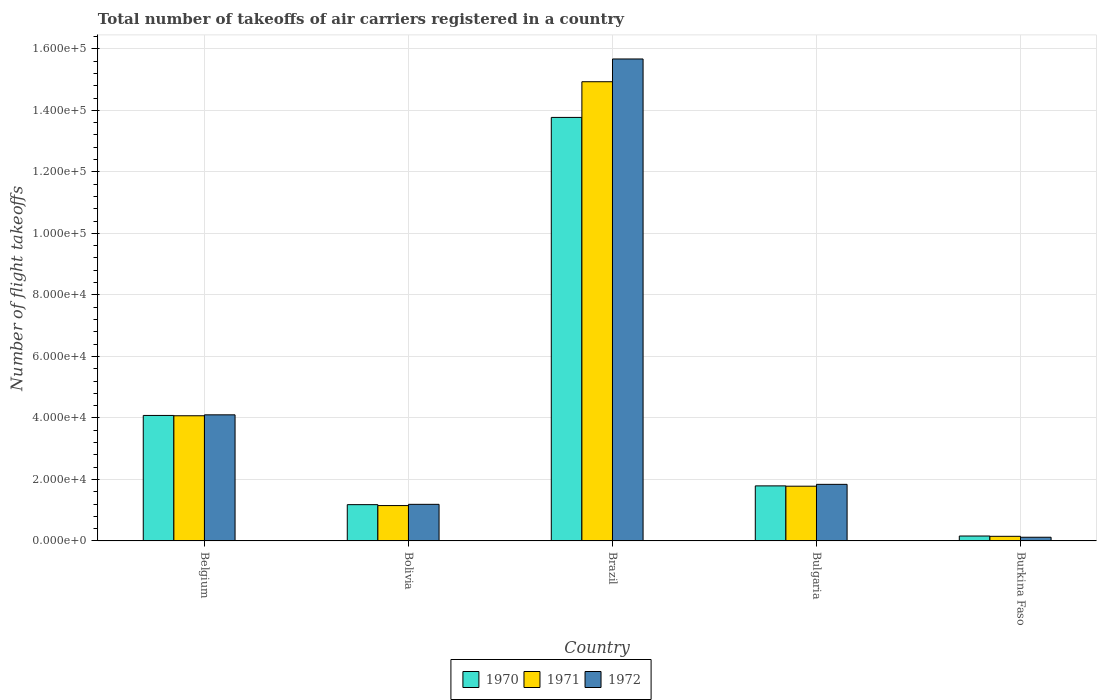What is the label of the 2nd group of bars from the left?
Provide a short and direct response. Bolivia. What is the total number of flight takeoffs in 1972 in Bulgaria?
Your answer should be compact. 1.84e+04. Across all countries, what is the maximum total number of flight takeoffs in 1971?
Keep it short and to the point. 1.49e+05. Across all countries, what is the minimum total number of flight takeoffs in 1971?
Give a very brief answer. 1500. In which country was the total number of flight takeoffs in 1972 minimum?
Make the answer very short. Burkina Faso. What is the total total number of flight takeoffs in 1971 in the graph?
Offer a terse response. 2.21e+05. What is the difference between the total number of flight takeoffs in 1970 in Belgium and that in Burkina Faso?
Provide a succinct answer. 3.92e+04. What is the difference between the total number of flight takeoffs in 1971 in Belgium and the total number of flight takeoffs in 1970 in Bulgaria?
Offer a very short reply. 2.28e+04. What is the average total number of flight takeoffs in 1971 per country?
Provide a succinct answer. 4.42e+04. What is the difference between the total number of flight takeoffs of/in 1970 and total number of flight takeoffs of/in 1972 in Belgium?
Offer a terse response. -200. What is the ratio of the total number of flight takeoffs in 1972 in Bolivia to that in Burkina Faso?
Your response must be concise. 9.92. Is the total number of flight takeoffs in 1972 in Bolivia less than that in Bulgaria?
Your answer should be compact. Yes. What is the difference between the highest and the second highest total number of flight takeoffs in 1972?
Your answer should be compact. 2.26e+04. What is the difference between the highest and the lowest total number of flight takeoffs in 1972?
Provide a succinct answer. 1.56e+05. In how many countries, is the total number of flight takeoffs in 1972 greater than the average total number of flight takeoffs in 1972 taken over all countries?
Offer a very short reply. 1. Is the sum of the total number of flight takeoffs in 1971 in Belgium and Brazil greater than the maximum total number of flight takeoffs in 1972 across all countries?
Your answer should be very brief. Yes. Is it the case that in every country, the sum of the total number of flight takeoffs in 1970 and total number of flight takeoffs in 1972 is greater than the total number of flight takeoffs in 1971?
Your answer should be compact. Yes. Are all the bars in the graph horizontal?
Keep it short and to the point. No. Are the values on the major ticks of Y-axis written in scientific E-notation?
Offer a very short reply. Yes. Does the graph contain grids?
Make the answer very short. Yes. How many legend labels are there?
Ensure brevity in your answer.  3. How are the legend labels stacked?
Provide a succinct answer. Horizontal. What is the title of the graph?
Provide a succinct answer. Total number of takeoffs of air carriers registered in a country. What is the label or title of the X-axis?
Offer a very short reply. Country. What is the label or title of the Y-axis?
Offer a terse response. Number of flight takeoffs. What is the Number of flight takeoffs of 1970 in Belgium?
Your response must be concise. 4.08e+04. What is the Number of flight takeoffs in 1971 in Belgium?
Your response must be concise. 4.07e+04. What is the Number of flight takeoffs of 1972 in Belgium?
Provide a succinct answer. 4.10e+04. What is the Number of flight takeoffs of 1970 in Bolivia?
Offer a terse response. 1.18e+04. What is the Number of flight takeoffs in 1971 in Bolivia?
Keep it short and to the point. 1.15e+04. What is the Number of flight takeoffs in 1972 in Bolivia?
Keep it short and to the point. 1.19e+04. What is the Number of flight takeoffs of 1970 in Brazil?
Offer a very short reply. 1.38e+05. What is the Number of flight takeoffs of 1971 in Brazil?
Offer a terse response. 1.49e+05. What is the Number of flight takeoffs in 1972 in Brazil?
Your answer should be very brief. 1.57e+05. What is the Number of flight takeoffs of 1970 in Bulgaria?
Your answer should be very brief. 1.79e+04. What is the Number of flight takeoffs of 1971 in Bulgaria?
Keep it short and to the point. 1.78e+04. What is the Number of flight takeoffs of 1972 in Bulgaria?
Offer a terse response. 1.84e+04. What is the Number of flight takeoffs in 1970 in Burkina Faso?
Your answer should be very brief. 1600. What is the Number of flight takeoffs of 1971 in Burkina Faso?
Your response must be concise. 1500. What is the Number of flight takeoffs in 1972 in Burkina Faso?
Make the answer very short. 1200. Across all countries, what is the maximum Number of flight takeoffs of 1970?
Offer a very short reply. 1.38e+05. Across all countries, what is the maximum Number of flight takeoffs of 1971?
Keep it short and to the point. 1.49e+05. Across all countries, what is the maximum Number of flight takeoffs of 1972?
Give a very brief answer. 1.57e+05. Across all countries, what is the minimum Number of flight takeoffs of 1970?
Your answer should be compact. 1600. Across all countries, what is the minimum Number of flight takeoffs of 1971?
Your answer should be very brief. 1500. Across all countries, what is the minimum Number of flight takeoffs in 1972?
Keep it short and to the point. 1200. What is the total Number of flight takeoffs of 1970 in the graph?
Make the answer very short. 2.10e+05. What is the total Number of flight takeoffs in 1971 in the graph?
Your response must be concise. 2.21e+05. What is the total Number of flight takeoffs in 1972 in the graph?
Offer a terse response. 2.29e+05. What is the difference between the Number of flight takeoffs in 1970 in Belgium and that in Bolivia?
Your answer should be very brief. 2.90e+04. What is the difference between the Number of flight takeoffs in 1971 in Belgium and that in Bolivia?
Your response must be concise. 2.92e+04. What is the difference between the Number of flight takeoffs in 1972 in Belgium and that in Bolivia?
Your response must be concise. 2.91e+04. What is the difference between the Number of flight takeoffs in 1970 in Belgium and that in Brazil?
Your answer should be very brief. -9.69e+04. What is the difference between the Number of flight takeoffs in 1971 in Belgium and that in Brazil?
Offer a terse response. -1.09e+05. What is the difference between the Number of flight takeoffs of 1972 in Belgium and that in Brazil?
Give a very brief answer. -1.16e+05. What is the difference between the Number of flight takeoffs of 1970 in Belgium and that in Bulgaria?
Your answer should be compact. 2.29e+04. What is the difference between the Number of flight takeoffs of 1971 in Belgium and that in Bulgaria?
Provide a short and direct response. 2.29e+04. What is the difference between the Number of flight takeoffs of 1972 in Belgium and that in Bulgaria?
Ensure brevity in your answer.  2.26e+04. What is the difference between the Number of flight takeoffs in 1970 in Belgium and that in Burkina Faso?
Give a very brief answer. 3.92e+04. What is the difference between the Number of flight takeoffs of 1971 in Belgium and that in Burkina Faso?
Offer a very short reply. 3.92e+04. What is the difference between the Number of flight takeoffs of 1972 in Belgium and that in Burkina Faso?
Give a very brief answer. 3.98e+04. What is the difference between the Number of flight takeoffs in 1970 in Bolivia and that in Brazil?
Provide a short and direct response. -1.26e+05. What is the difference between the Number of flight takeoffs in 1971 in Bolivia and that in Brazil?
Keep it short and to the point. -1.38e+05. What is the difference between the Number of flight takeoffs of 1972 in Bolivia and that in Brazil?
Offer a very short reply. -1.45e+05. What is the difference between the Number of flight takeoffs of 1970 in Bolivia and that in Bulgaria?
Ensure brevity in your answer.  -6100. What is the difference between the Number of flight takeoffs in 1971 in Bolivia and that in Bulgaria?
Your answer should be very brief. -6300. What is the difference between the Number of flight takeoffs in 1972 in Bolivia and that in Bulgaria?
Make the answer very short. -6500. What is the difference between the Number of flight takeoffs of 1970 in Bolivia and that in Burkina Faso?
Provide a short and direct response. 1.02e+04. What is the difference between the Number of flight takeoffs in 1972 in Bolivia and that in Burkina Faso?
Ensure brevity in your answer.  1.07e+04. What is the difference between the Number of flight takeoffs of 1970 in Brazil and that in Bulgaria?
Offer a terse response. 1.20e+05. What is the difference between the Number of flight takeoffs of 1971 in Brazil and that in Bulgaria?
Offer a terse response. 1.32e+05. What is the difference between the Number of flight takeoffs in 1972 in Brazil and that in Bulgaria?
Give a very brief answer. 1.38e+05. What is the difference between the Number of flight takeoffs in 1970 in Brazil and that in Burkina Faso?
Make the answer very short. 1.36e+05. What is the difference between the Number of flight takeoffs of 1971 in Brazil and that in Burkina Faso?
Offer a terse response. 1.48e+05. What is the difference between the Number of flight takeoffs in 1972 in Brazil and that in Burkina Faso?
Provide a short and direct response. 1.56e+05. What is the difference between the Number of flight takeoffs in 1970 in Bulgaria and that in Burkina Faso?
Your response must be concise. 1.63e+04. What is the difference between the Number of flight takeoffs in 1971 in Bulgaria and that in Burkina Faso?
Your answer should be very brief. 1.63e+04. What is the difference between the Number of flight takeoffs of 1972 in Bulgaria and that in Burkina Faso?
Your answer should be very brief. 1.72e+04. What is the difference between the Number of flight takeoffs in 1970 in Belgium and the Number of flight takeoffs in 1971 in Bolivia?
Provide a short and direct response. 2.93e+04. What is the difference between the Number of flight takeoffs of 1970 in Belgium and the Number of flight takeoffs of 1972 in Bolivia?
Provide a short and direct response. 2.89e+04. What is the difference between the Number of flight takeoffs in 1971 in Belgium and the Number of flight takeoffs in 1972 in Bolivia?
Give a very brief answer. 2.88e+04. What is the difference between the Number of flight takeoffs in 1970 in Belgium and the Number of flight takeoffs in 1971 in Brazil?
Ensure brevity in your answer.  -1.08e+05. What is the difference between the Number of flight takeoffs of 1970 in Belgium and the Number of flight takeoffs of 1972 in Brazil?
Offer a terse response. -1.16e+05. What is the difference between the Number of flight takeoffs in 1971 in Belgium and the Number of flight takeoffs in 1972 in Brazil?
Give a very brief answer. -1.16e+05. What is the difference between the Number of flight takeoffs in 1970 in Belgium and the Number of flight takeoffs in 1971 in Bulgaria?
Your response must be concise. 2.30e+04. What is the difference between the Number of flight takeoffs in 1970 in Belgium and the Number of flight takeoffs in 1972 in Bulgaria?
Your answer should be very brief. 2.24e+04. What is the difference between the Number of flight takeoffs in 1971 in Belgium and the Number of flight takeoffs in 1972 in Bulgaria?
Offer a very short reply. 2.23e+04. What is the difference between the Number of flight takeoffs in 1970 in Belgium and the Number of flight takeoffs in 1971 in Burkina Faso?
Give a very brief answer. 3.93e+04. What is the difference between the Number of flight takeoffs of 1970 in Belgium and the Number of flight takeoffs of 1972 in Burkina Faso?
Offer a very short reply. 3.96e+04. What is the difference between the Number of flight takeoffs of 1971 in Belgium and the Number of flight takeoffs of 1972 in Burkina Faso?
Offer a terse response. 3.95e+04. What is the difference between the Number of flight takeoffs of 1970 in Bolivia and the Number of flight takeoffs of 1971 in Brazil?
Offer a very short reply. -1.38e+05. What is the difference between the Number of flight takeoffs in 1970 in Bolivia and the Number of flight takeoffs in 1972 in Brazil?
Your answer should be compact. -1.45e+05. What is the difference between the Number of flight takeoffs of 1971 in Bolivia and the Number of flight takeoffs of 1972 in Brazil?
Offer a very short reply. -1.45e+05. What is the difference between the Number of flight takeoffs in 1970 in Bolivia and the Number of flight takeoffs in 1971 in Bulgaria?
Provide a short and direct response. -6000. What is the difference between the Number of flight takeoffs in 1970 in Bolivia and the Number of flight takeoffs in 1972 in Bulgaria?
Ensure brevity in your answer.  -6600. What is the difference between the Number of flight takeoffs of 1971 in Bolivia and the Number of flight takeoffs of 1972 in Bulgaria?
Your response must be concise. -6900. What is the difference between the Number of flight takeoffs in 1970 in Bolivia and the Number of flight takeoffs in 1971 in Burkina Faso?
Make the answer very short. 1.03e+04. What is the difference between the Number of flight takeoffs in 1970 in Bolivia and the Number of flight takeoffs in 1972 in Burkina Faso?
Keep it short and to the point. 1.06e+04. What is the difference between the Number of flight takeoffs in 1971 in Bolivia and the Number of flight takeoffs in 1972 in Burkina Faso?
Offer a terse response. 1.03e+04. What is the difference between the Number of flight takeoffs of 1970 in Brazil and the Number of flight takeoffs of 1971 in Bulgaria?
Give a very brief answer. 1.20e+05. What is the difference between the Number of flight takeoffs of 1970 in Brazil and the Number of flight takeoffs of 1972 in Bulgaria?
Give a very brief answer. 1.19e+05. What is the difference between the Number of flight takeoffs of 1971 in Brazil and the Number of flight takeoffs of 1972 in Bulgaria?
Give a very brief answer. 1.31e+05. What is the difference between the Number of flight takeoffs of 1970 in Brazil and the Number of flight takeoffs of 1971 in Burkina Faso?
Your response must be concise. 1.36e+05. What is the difference between the Number of flight takeoffs in 1970 in Brazil and the Number of flight takeoffs in 1972 in Burkina Faso?
Give a very brief answer. 1.36e+05. What is the difference between the Number of flight takeoffs in 1971 in Brazil and the Number of flight takeoffs in 1972 in Burkina Faso?
Make the answer very short. 1.48e+05. What is the difference between the Number of flight takeoffs in 1970 in Bulgaria and the Number of flight takeoffs in 1971 in Burkina Faso?
Your response must be concise. 1.64e+04. What is the difference between the Number of flight takeoffs of 1970 in Bulgaria and the Number of flight takeoffs of 1972 in Burkina Faso?
Provide a succinct answer. 1.67e+04. What is the difference between the Number of flight takeoffs in 1971 in Bulgaria and the Number of flight takeoffs in 1972 in Burkina Faso?
Keep it short and to the point. 1.66e+04. What is the average Number of flight takeoffs of 1970 per country?
Your response must be concise. 4.20e+04. What is the average Number of flight takeoffs of 1971 per country?
Provide a short and direct response. 4.42e+04. What is the average Number of flight takeoffs in 1972 per country?
Your answer should be very brief. 4.58e+04. What is the difference between the Number of flight takeoffs of 1970 and Number of flight takeoffs of 1971 in Belgium?
Offer a very short reply. 100. What is the difference between the Number of flight takeoffs in 1970 and Number of flight takeoffs in 1972 in Belgium?
Keep it short and to the point. -200. What is the difference between the Number of flight takeoffs in 1971 and Number of flight takeoffs in 1972 in Belgium?
Offer a terse response. -300. What is the difference between the Number of flight takeoffs of 1970 and Number of flight takeoffs of 1971 in Bolivia?
Provide a succinct answer. 300. What is the difference between the Number of flight takeoffs in 1970 and Number of flight takeoffs in 1972 in Bolivia?
Your response must be concise. -100. What is the difference between the Number of flight takeoffs of 1971 and Number of flight takeoffs of 1972 in Bolivia?
Your answer should be very brief. -400. What is the difference between the Number of flight takeoffs of 1970 and Number of flight takeoffs of 1971 in Brazil?
Give a very brief answer. -1.16e+04. What is the difference between the Number of flight takeoffs in 1970 and Number of flight takeoffs in 1972 in Brazil?
Make the answer very short. -1.90e+04. What is the difference between the Number of flight takeoffs of 1971 and Number of flight takeoffs of 1972 in Brazil?
Provide a short and direct response. -7400. What is the difference between the Number of flight takeoffs of 1970 and Number of flight takeoffs of 1972 in Bulgaria?
Offer a terse response. -500. What is the difference between the Number of flight takeoffs in 1971 and Number of flight takeoffs in 1972 in Bulgaria?
Keep it short and to the point. -600. What is the difference between the Number of flight takeoffs in 1970 and Number of flight takeoffs in 1972 in Burkina Faso?
Provide a succinct answer. 400. What is the difference between the Number of flight takeoffs of 1971 and Number of flight takeoffs of 1972 in Burkina Faso?
Provide a short and direct response. 300. What is the ratio of the Number of flight takeoffs of 1970 in Belgium to that in Bolivia?
Your answer should be very brief. 3.46. What is the ratio of the Number of flight takeoffs of 1971 in Belgium to that in Bolivia?
Ensure brevity in your answer.  3.54. What is the ratio of the Number of flight takeoffs in 1972 in Belgium to that in Bolivia?
Make the answer very short. 3.45. What is the ratio of the Number of flight takeoffs of 1970 in Belgium to that in Brazil?
Your response must be concise. 0.3. What is the ratio of the Number of flight takeoffs of 1971 in Belgium to that in Brazil?
Your answer should be very brief. 0.27. What is the ratio of the Number of flight takeoffs of 1972 in Belgium to that in Brazil?
Offer a very short reply. 0.26. What is the ratio of the Number of flight takeoffs of 1970 in Belgium to that in Bulgaria?
Offer a terse response. 2.28. What is the ratio of the Number of flight takeoffs in 1971 in Belgium to that in Bulgaria?
Your answer should be very brief. 2.29. What is the ratio of the Number of flight takeoffs in 1972 in Belgium to that in Bulgaria?
Make the answer very short. 2.23. What is the ratio of the Number of flight takeoffs of 1971 in Belgium to that in Burkina Faso?
Offer a very short reply. 27.13. What is the ratio of the Number of flight takeoffs of 1972 in Belgium to that in Burkina Faso?
Your answer should be compact. 34.17. What is the ratio of the Number of flight takeoffs in 1970 in Bolivia to that in Brazil?
Give a very brief answer. 0.09. What is the ratio of the Number of flight takeoffs of 1971 in Bolivia to that in Brazil?
Keep it short and to the point. 0.08. What is the ratio of the Number of flight takeoffs in 1972 in Bolivia to that in Brazil?
Keep it short and to the point. 0.08. What is the ratio of the Number of flight takeoffs in 1970 in Bolivia to that in Bulgaria?
Provide a short and direct response. 0.66. What is the ratio of the Number of flight takeoffs of 1971 in Bolivia to that in Bulgaria?
Your answer should be very brief. 0.65. What is the ratio of the Number of flight takeoffs in 1972 in Bolivia to that in Bulgaria?
Offer a very short reply. 0.65. What is the ratio of the Number of flight takeoffs in 1970 in Bolivia to that in Burkina Faso?
Offer a very short reply. 7.38. What is the ratio of the Number of flight takeoffs in 1971 in Bolivia to that in Burkina Faso?
Offer a very short reply. 7.67. What is the ratio of the Number of flight takeoffs of 1972 in Bolivia to that in Burkina Faso?
Make the answer very short. 9.92. What is the ratio of the Number of flight takeoffs of 1970 in Brazil to that in Bulgaria?
Keep it short and to the point. 7.69. What is the ratio of the Number of flight takeoffs in 1971 in Brazil to that in Bulgaria?
Give a very brief answer. 8.39. What is the ratio of the Number of flight takeoffs of 1972 in Brazil to that in Bulgaria?
Your answer should be compact. 8.52. What is the ratio of the Number of flight takeoffs in 1970 in Brazil to that in Burkina Faso?
Offer a terse response. 86.06. What is the ratio of the Number of flight takeoffs in 1971 in Brazil to that in Burkina Faso?
Your answer should be very brief. 99.53. What is the ratio of the Number of flight takeoffs of 1972 in Brazil to that in Burkina Faso?
Your response must be concise. 130.58. What is the ratio of the Number of flight takeoffs in 1970 in Bulgaria to that in Burkina Faso?
Ensure brevity in your answer.  11.19. What is the ratio of the Number of flight takeoffs of 1971 in Bulgaria to that in Burkina Faso?
Provide a succinct answer. 11.87. What is the ratio of the Number of flight takeoffs of 1972 in Bulgaria to that in Burkina Faso?
Your response must be concise. 15.33. What is the difference between the highest and the second highest Number of flight takeoffs of 1970?
Give a very brief answer. 9.69e+04. What is the difference between the highest and the second highest Number of flight takeoffs of 1971?
Ensure brevity in your answer.  1.09e+05. What is the difference between the highest and the second highest Number of flight takeoffs of 1972?
Your answer should be very brief. 1.16e+05. What is the difference between the highest and the lowest Number of flight takeoffs in 1970?
Provide a short and direct response. 1.36e+05. What is the difference between the highest and the lowest Number of flight takeoffs in 1971?
Make the answer very short. 1.48e+05. What is the difference between the highest and the lowest Number of flight takeoffs in 1972?
Make the answer very short. 1.56e+05. 